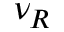<formula> <loc_0><loc_0><loc_500><loc_500>\nu _ { R }</formula> 